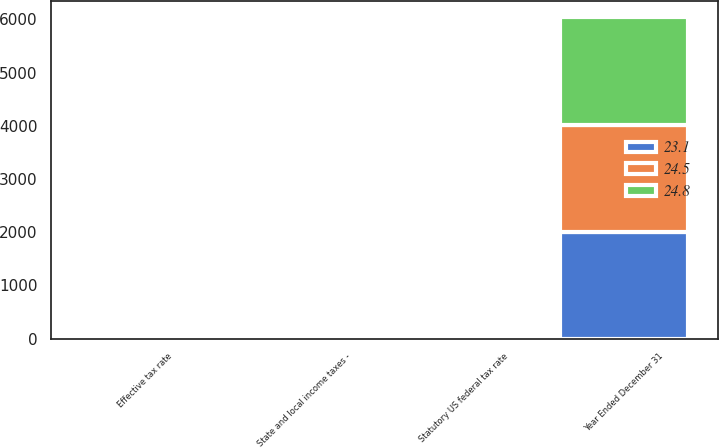<chart> <loc_0><loc_0><loc_500><loc_500><stacked_bar_chart><ecel><fcel>Year Ended December 31<fcel>Statutory US federal tax rate<fcel>State and local income taxes -<fcel>Effective tax rate<nl><fcel>23.1<fcel>2013<fcel>35<fcel>1<fcel>24.8<nl><fcel>24.8<fcel>2012<fcel>35<fcel>1.1<fcel>23.1<nl><fcel>24.5<fcel>2011<fcel>35<fcel>0.9<fcel>24.5<nl></chart> 